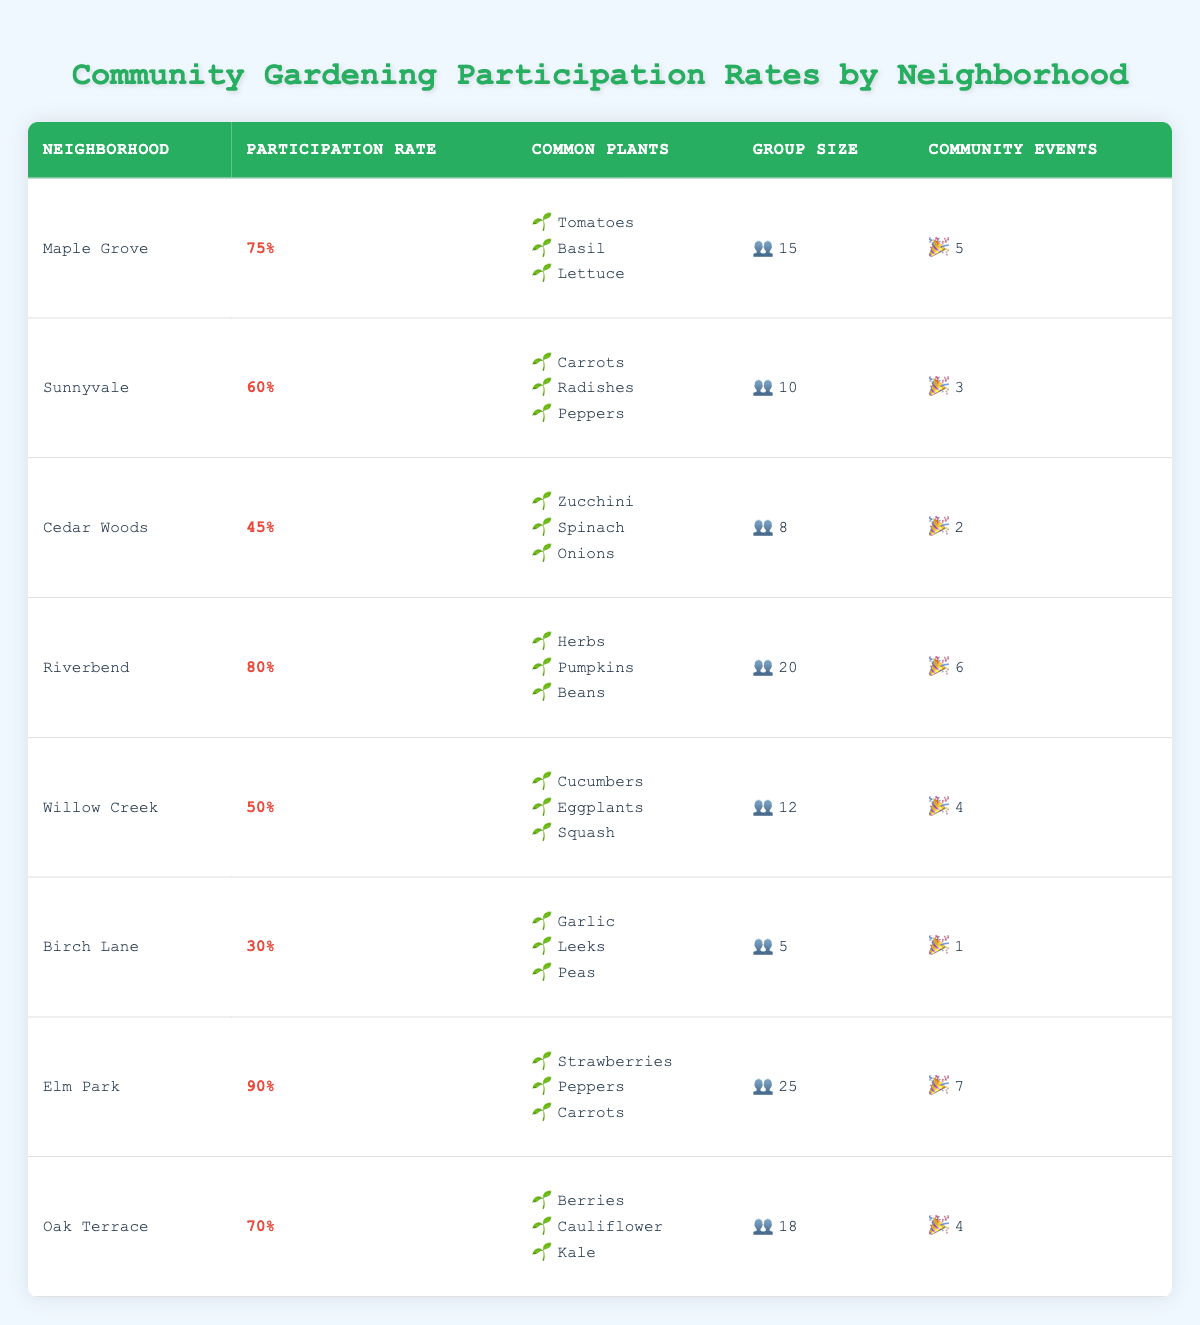What is the participation rate for Riverbend? The table lists Riverbend's participation rate in the corresponding row. It shows a participation rate of 80%.
Answer: 80% Which neighborhood has the highest participation rate? By comparing the participation rates of each neighborhood in the table, Elm Park has the highest with a rate of 90%.
Answer: Elm Park How many community events does Birch Lane have? The table explicitly states the number of community events for Birch Lane in the corresponding row, which is 1.
Answer: 1 What is the average participation rate across all neighborhoods? To get the average participation rate, I add all participation rates: (75 + 60 + 45 + 80 + 50 + 30 + 90 + 70) = 500. There are 8 neighborhoods, so I divide by 8: 500/8 = 62.5.
Answer: 62.5 Do more community events correlate with a higher participation rate? To analyze this, I compare neighborhoods with the highest and lowest participation rates and their community events. Elm Park has the highest participation (90%) and 7 events, while Birch Lane has the lowest (30%) and only 1 event. This suggests yes, but requires more data for a definitive correlation.
Answer: Yes How many common plants are listed for Oak Terrace? The table shows Oak Terrace's common plants in a bulleted list. It lists three plants: Berries, Cauliflower, and Kale, totaling three.
Answer: 3 What neighborhood has the smallest group size, and what is that size? Upon examining the table, Birch Lane has the smallest group size listed, which is 5.
Answer: Birch Lane, 5 Is there a neighborhood with a participation rate below 40%? By reviewing the table, it is evident that Birch Lane has a participation rate of 30%, confirming that there is indeed a neighborhood below 40%.
Answer: Yes Which neighborhood has a participation rate in the 50s? I look for neighborhoods with participation rates in the 50% range. From the table, Willow Creek has a participation rate of 50%.
Answer: Willow Creek 